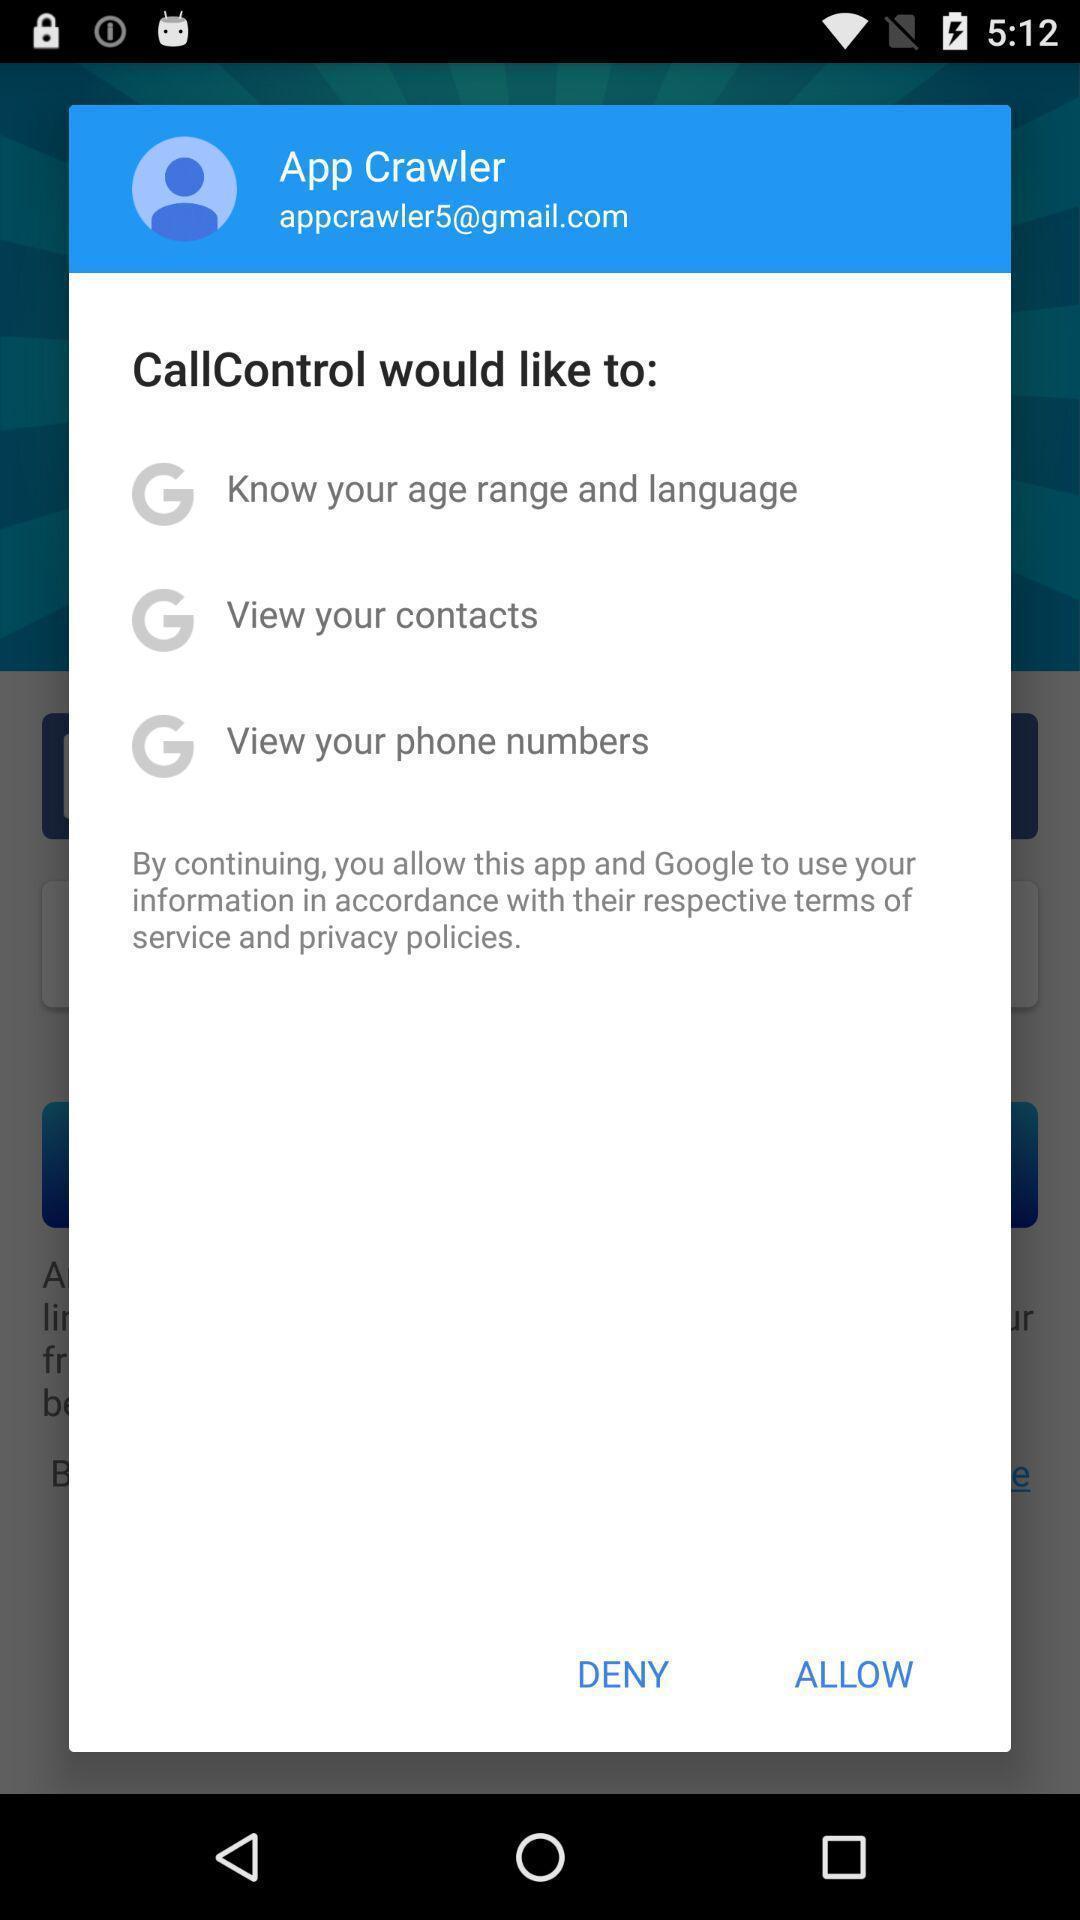Explain the elements present in this screenshot. Pop-up showing options like deny or allow. 